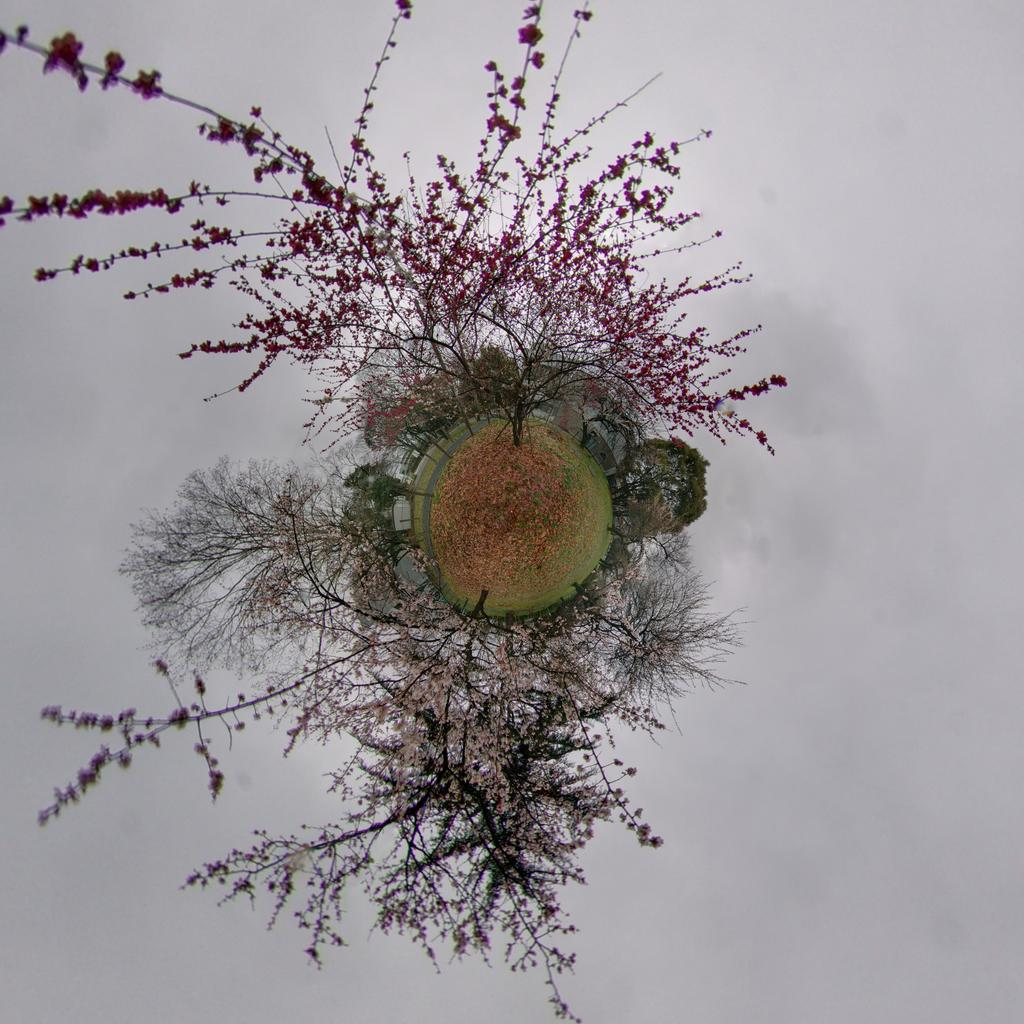What type of vegetation can be seen in the image? There are flowers on plants and trees in the image. Can you describe the flowers in more detail? The flowers are on both plants and trees, but no specific details about the flowers are provided. What is the setting of the image? The image features flowers on plants and trees, but no specific location or context is given. Where is the faucet located in the image? There is no faucet present in the image. What type of pail is being used to collect the flowers in the image? There is no pail or any indication of collecting flowers in the image. 